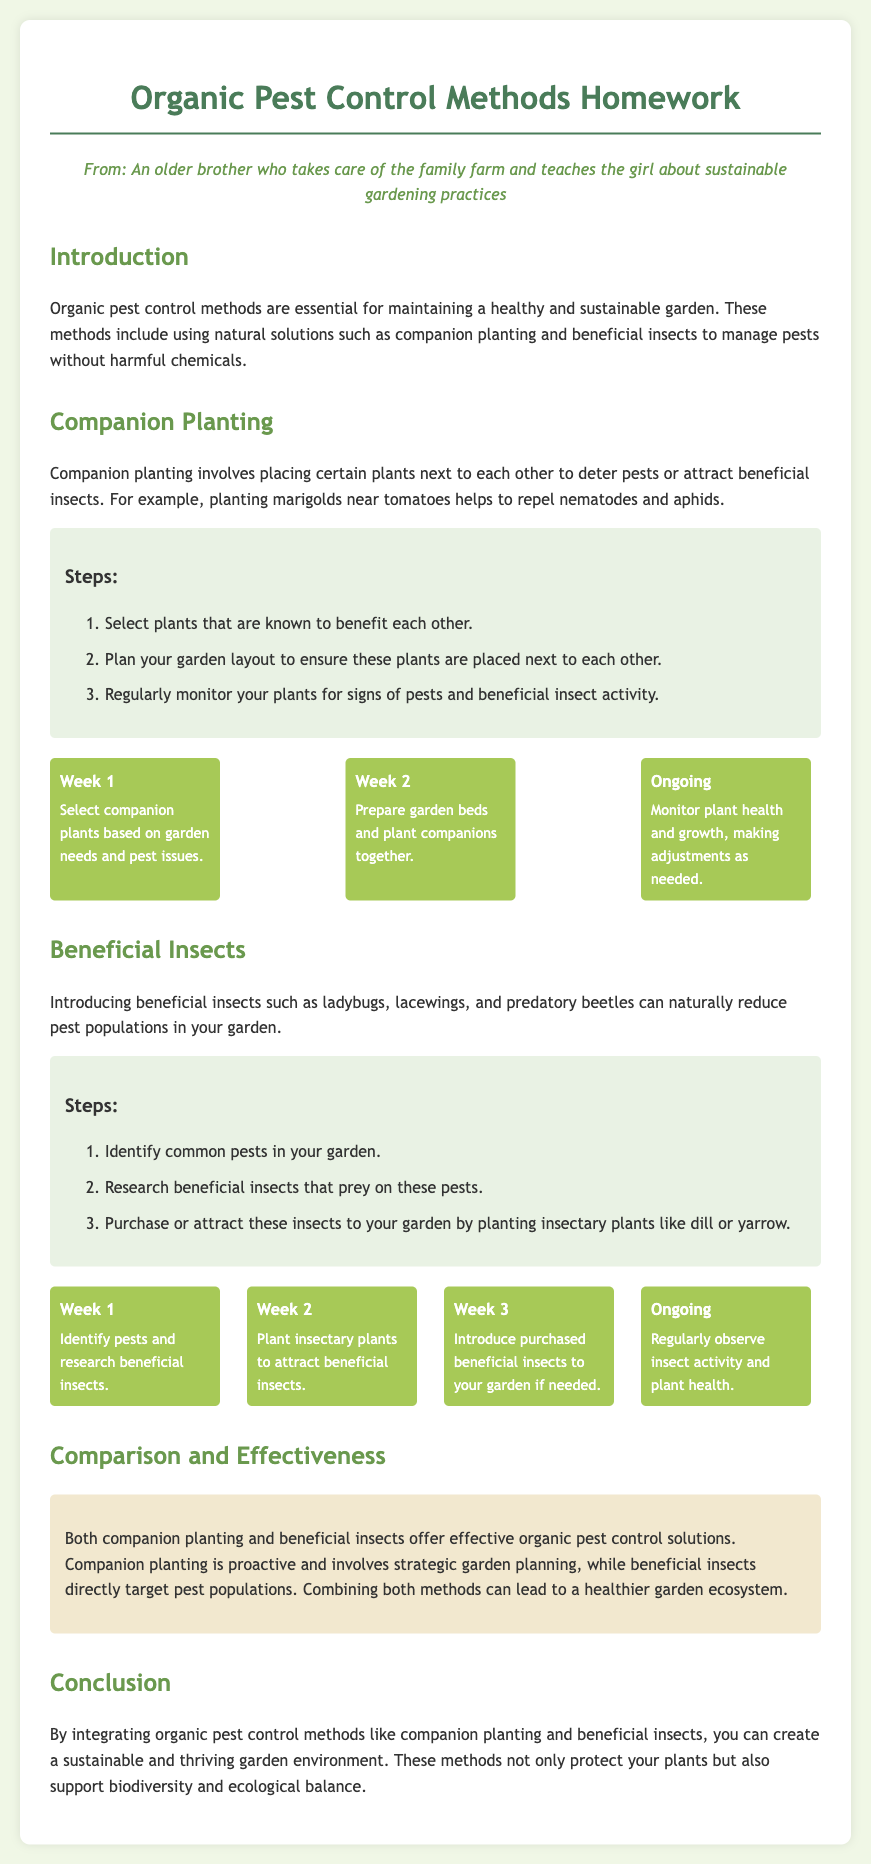What are two organic pest control methods mentioned in the document? The document mentions companion planting and beneficial insects as organic pest control methods.
Answer: companion planting, beneficial insects What is the first step in companion planting? The first step involves selecting plants that are known to benefit each other.
Answer: Select plants How long is the ongoing monitoring phase for companion planting? The ongoing phase for monitoring plant health and growth is detailed as ongoing in the timeline.
Answer: Ongoing What type of beneficial insect is mentioned as being useful for pest control? Ladybugs are mentioned as one of the beneficial insects that can help with pest control.
Answer: Ladybugs What should you plant to attract beneficial insects? The document states that you can plant insectary plants like dill or yarrow to attract beneficial insects.
Answer: Dill, yarrow How many weeks does it take to plant companion plants according to the timeline? The timeline indicates two weeks are designated for preparing and planting companion plants.
Answer: 2 weeks What do both organic pest control methods contribute to besides pest control? Both methods support biodiversity and ecological balance in the garden environment.
Answer: Biodiversity, ecological balance What is an example of a flower that can deter pests when planted with vegetables? Marigolds are provided as an example of a flower that can repel pests.
Answer: Marigolds 